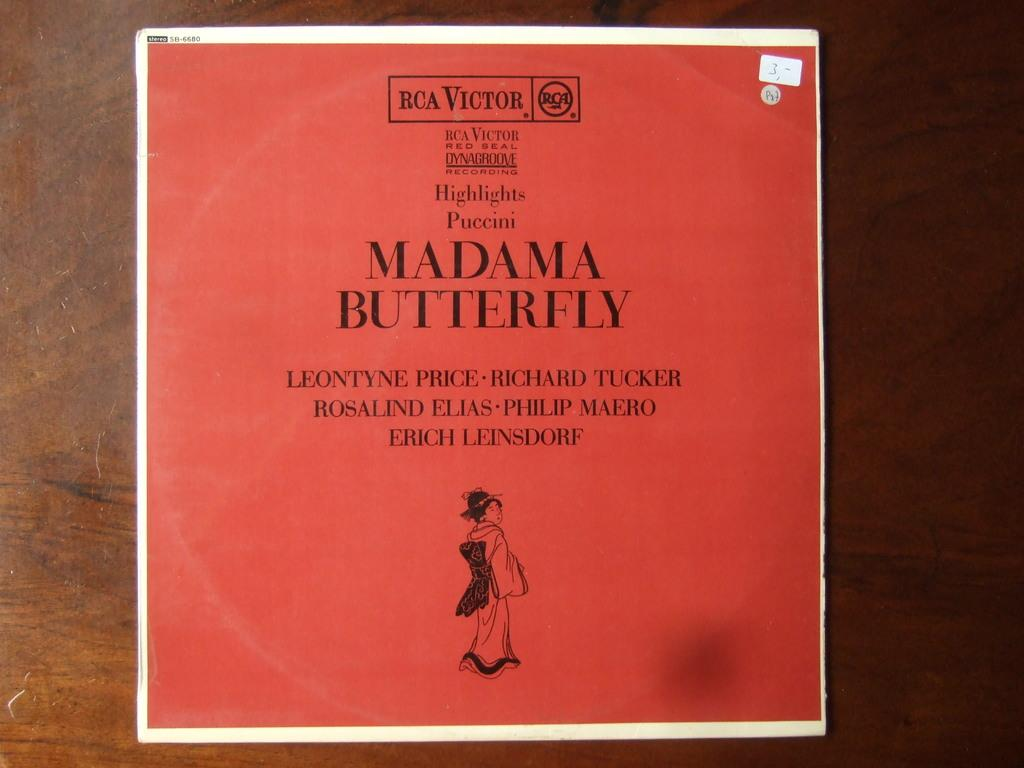<image>
Render a clear and concise summary of the photo. A red document with MAdama Butterfly written on it. 